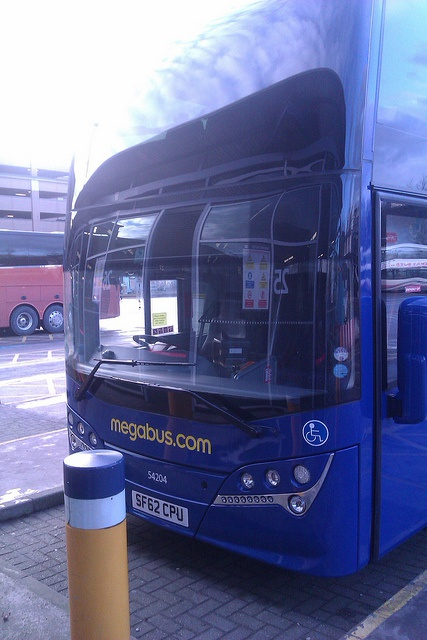Describe the objects in this image and their specific colors. I can see bus in white, navy, gray, and lightblue tones and bus in white, violet, gray, and lavender tones in this image. 